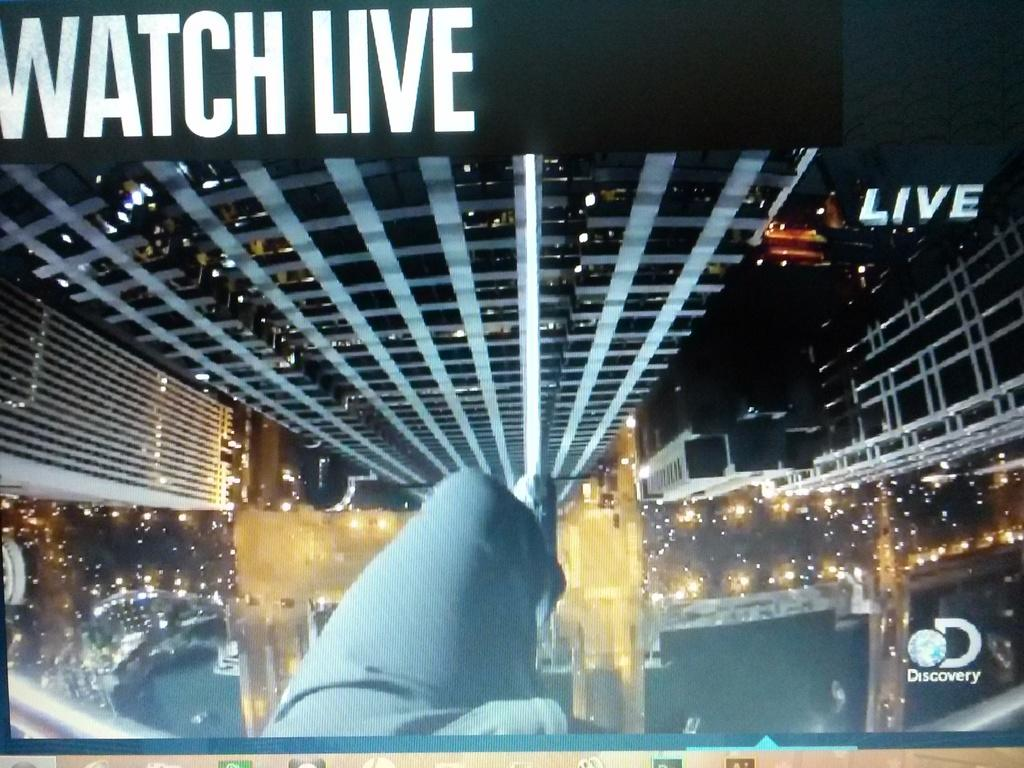What type of content is featured in the image? The image contains an animation. Is there any written information in the image? Yes, there is text present in the image. What type of corn is growing in the image? There is no corn present in the image; it contains an animation and text. How many clovers can be seen in the image? There are no clovers present in the image; it contains an animation and text. 